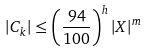<formula> <loc_0><loc_0><loc_500><loc_500>| C _ { k } | \leq \left ( \frac { 9 4 } { 1 0 0 } \right ) ^ { h } | X | ^ { m }</formula> 